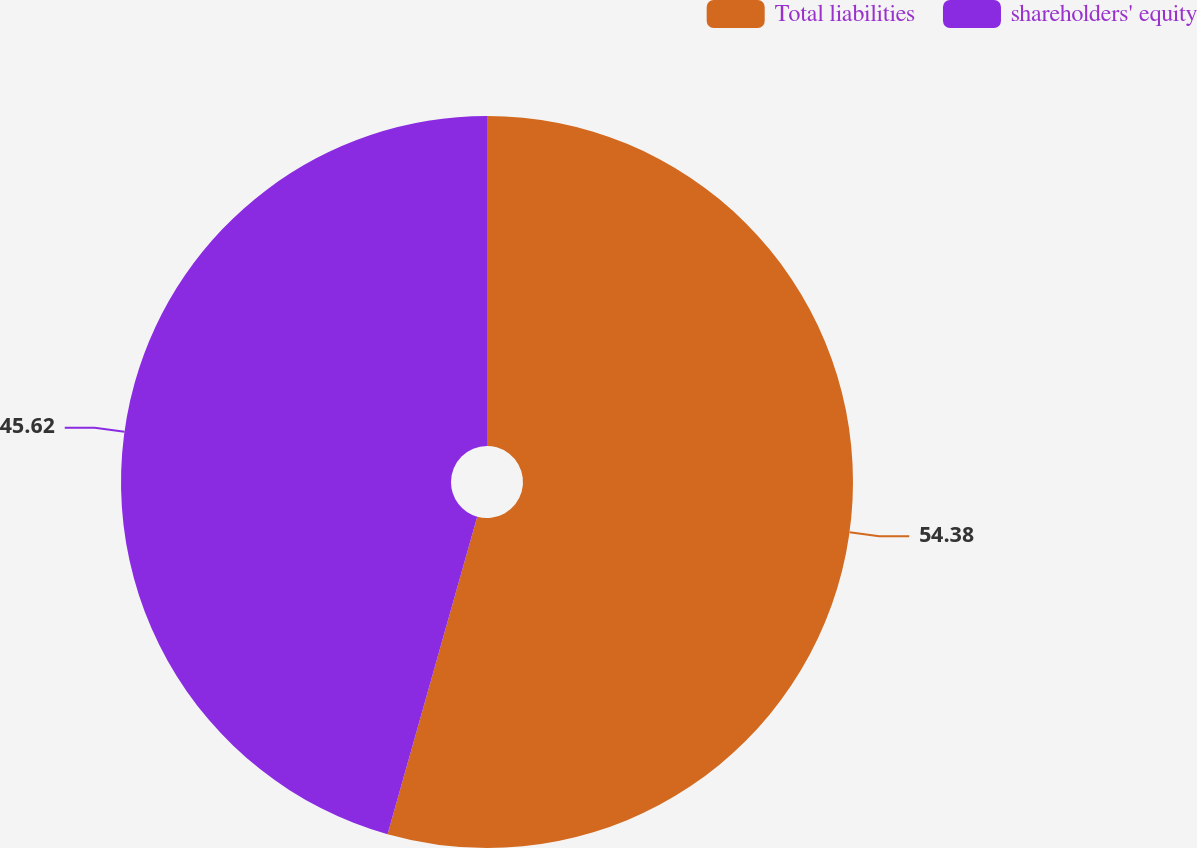<chart> <loc_0><loc_0><loc_500><loc_500><pie_chart><fcel>Total liabilities<fcel>shareholders' equity<nl><fcel>54.38%<fcel>45.62%<nl></chart> 